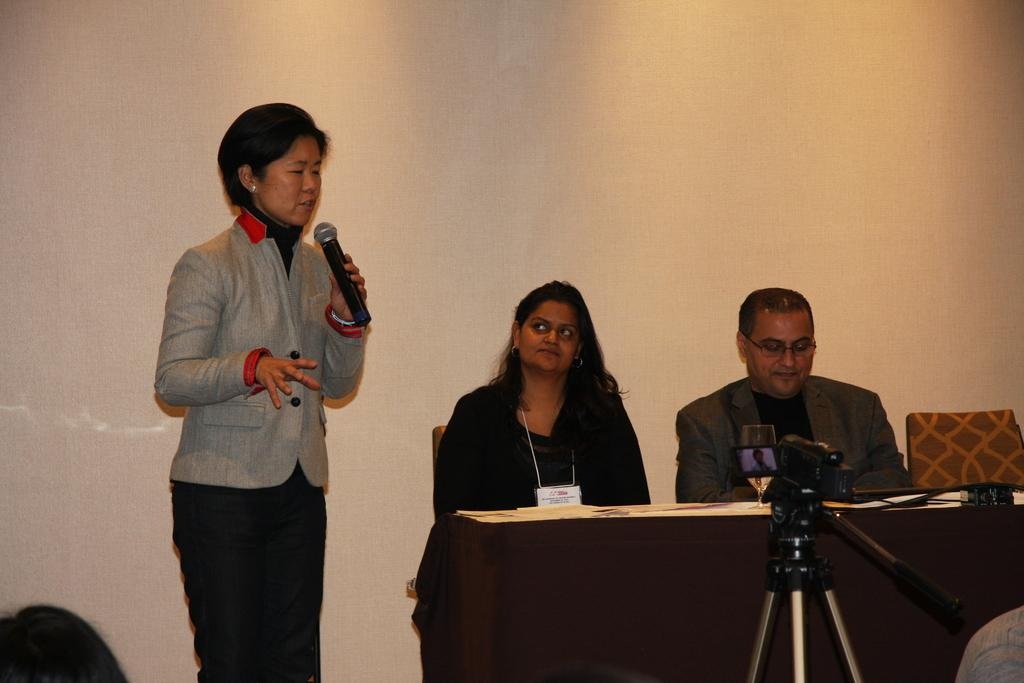What is the woman in the image holding in her hand? The woman is holding a mic in her hand. How many people are present in the image? There are three people in the image: a woman, a man, and another woman. What are the people in the image doing? They are sitting in chairs and speaking. What is the setting of the image? They are seated at a table, and there is a video camera in front of them. What type of sand can be seen on the table in the image? There is no sand present on the table in the image. How many things are on the table in the image? It is not clear how many "things" are on the table in the image, as the provided facts only mention a video camera. 